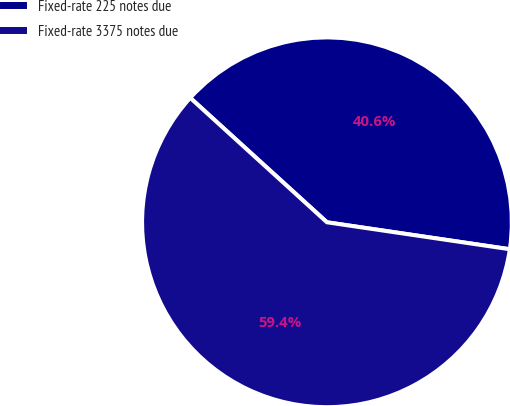<chart> <loc_0><loc_0><loc_500><loc_500><pie_chart><fcel>Fixed-rate 225 notes due<fcel>Fixed-rate 3375 notes due<nl><fcel>40.58%<fcel>59.42%<nl></chart> 